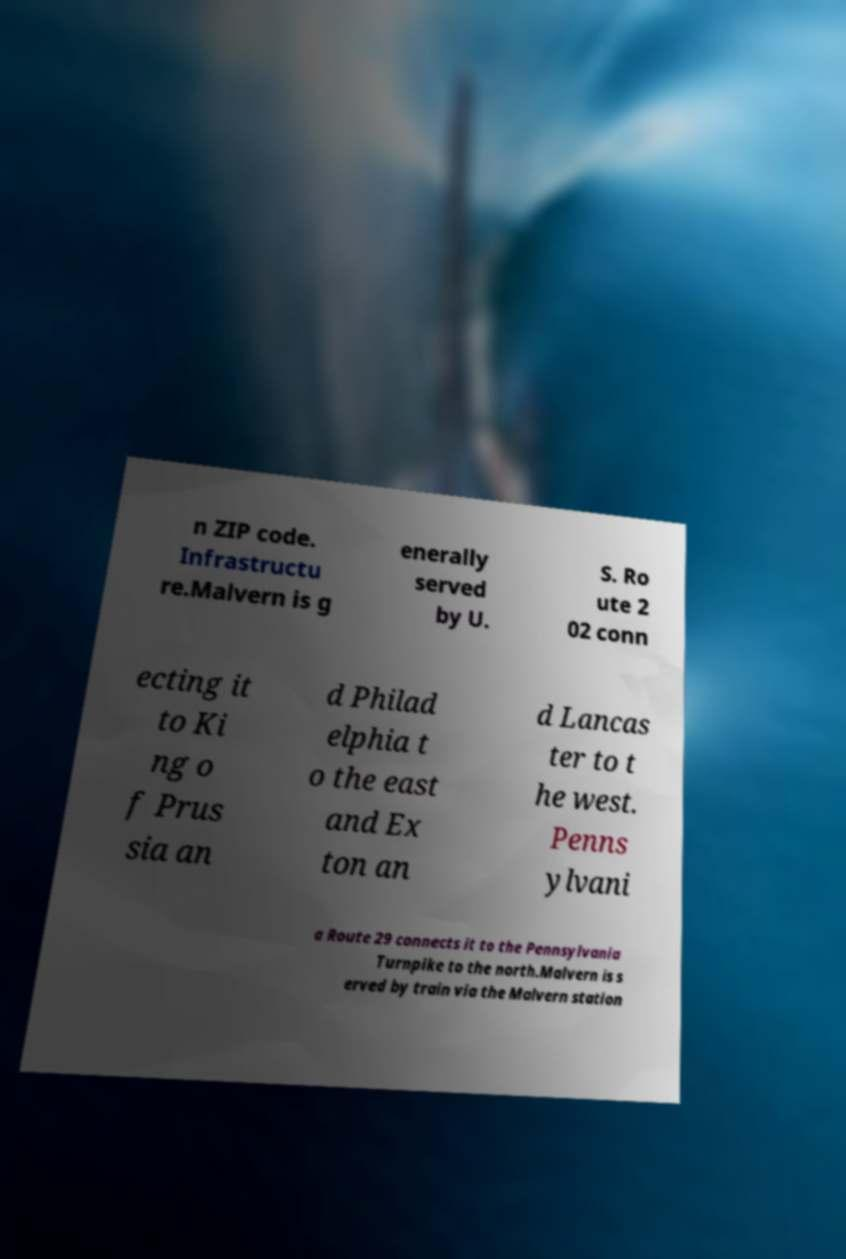Please identify and transcribe the text found in this image. n ZIP code. Infrastructu re.Malvern is g enerally served by U. S. Ro ute 2 02 conn ecting it to Ki ng o f Prus sia an d Philad elphia t o the east and Ex ton an d Lancas ter to t he west. Penns ylvani a Route 29 connects it to the Pennsylvania Turnpike to the north.Malvern is s erved by train via the Malvern station 